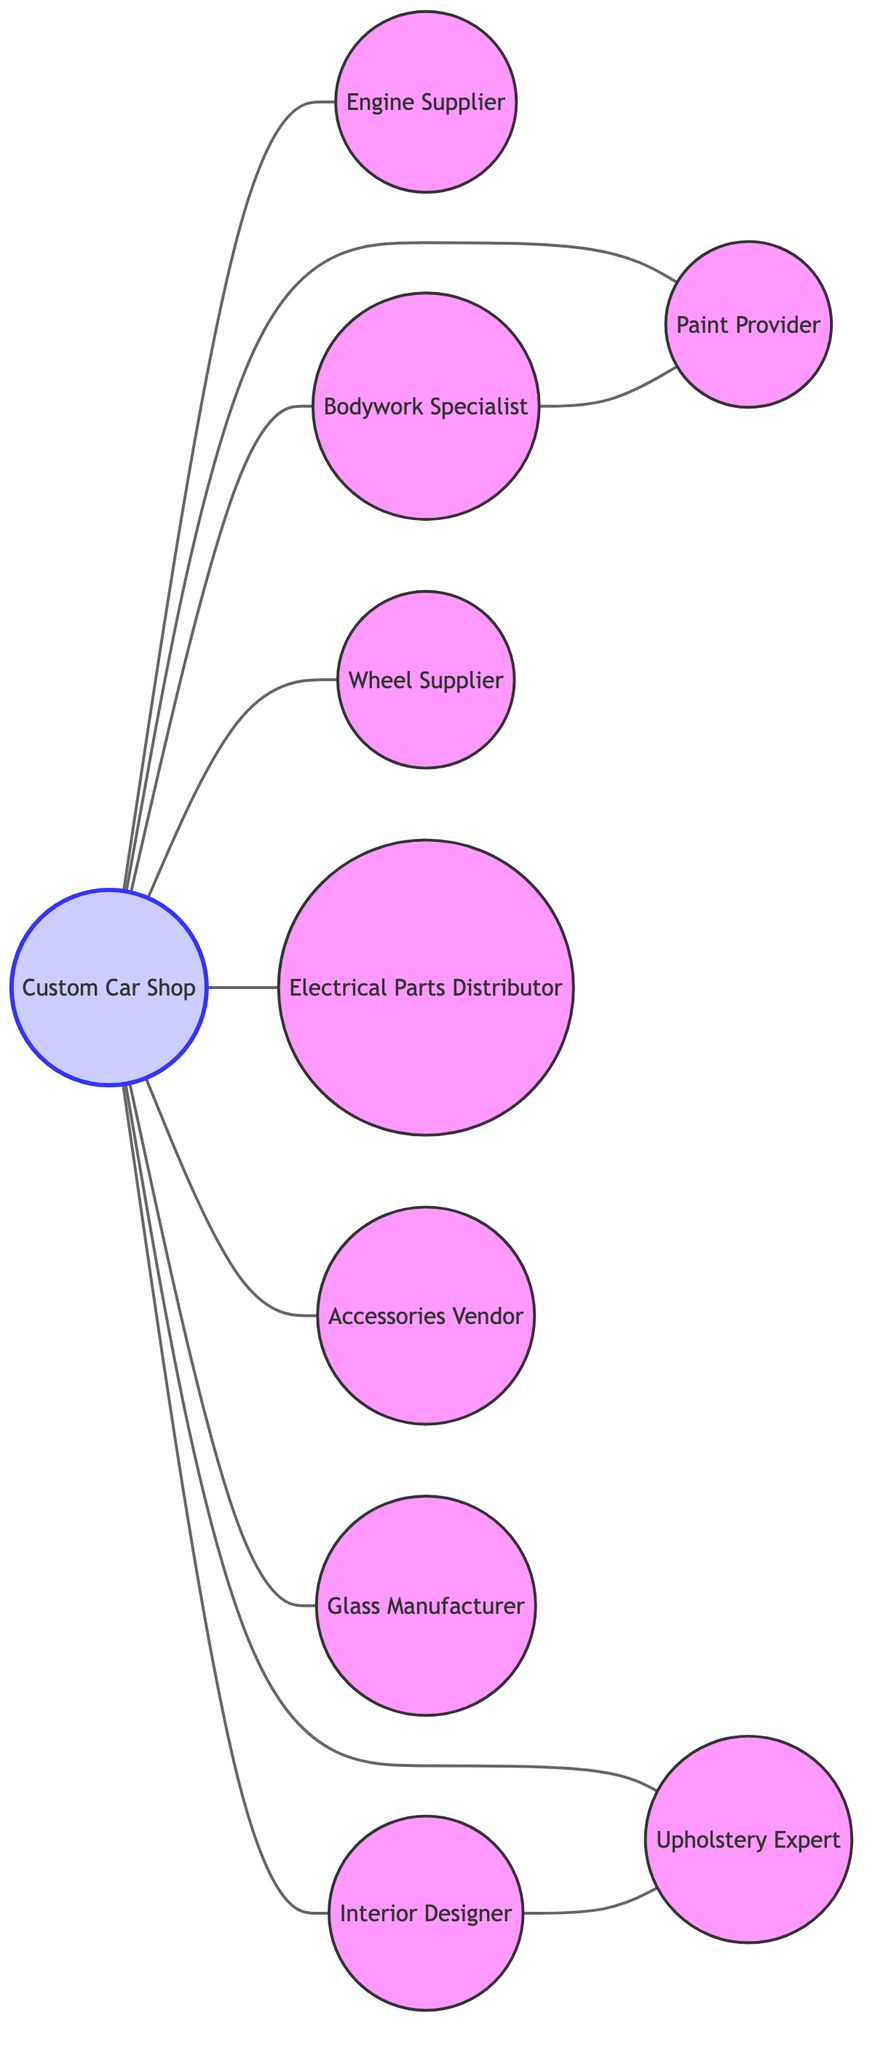What is the number of nodes in the diagram? The diagram contains a total of 10 nodes as listed, including the Custom Car Shop and all the various suppliers and specialists.
Answer: 10 Which supplier is directly connected to the Custom Car Shop? The Custom Car Shop is directly connected to nine suppliers, including engine supplier, bodywork specialist, paint provider, interior designer, wheel supplier, electrical parts distributor, accessories vendor, glass manufacturer, and upholstery expert.
Answer: Nine How many edges are present in the graph? By counting the edges listed, there are 10 edges present in the graph indicating the connections between the nodes.
Answer: 10 Which nodes are indirectly connected through the bodywork specialist? The bodywork specialist is connected to the paint provider, indicating that any connection from the Custom Car Shop to the bodywork specialist will lead to the paint provider.
Answer: Paint Provider How many suppliers are connected to the interior designer? The interior designer is directly connected to one supplier: the upholstery expert, showing a direct relationship in the graph.
Answer: One Which two suppliers are related through multiple connections? The engine supplier and upholstery expert are not directly but are part of a network with the Custom Car Shop as the central node, indicating an indirect relationship.
Answer: Custom Car Shop Is there a direct connection between the glass manufacturer and the accessories vendor? The graph indicates that there are no direct connections between the glass manufacturer and the accessories vendor, they are only connected through the Custom Car Shop.
Answer: No What are the roles of the connected nodes to the paint provider? The connected nodes to the paint provider are bodywork specialist and the Custom Car Shop, indicating that they are involved in a project involving paint application.
Answer: Custom Car Shop, Bodywork Specialist How many specialists have a direct relationship with the Custom Car Shop? The Custom Car Shop has direct relationships with eight specialists: engine supplier, bodywork specialist, paint provider, interior designer, wheel supplier, electrical parts distributor, accessories vendor, glass manufacturer, and upholstery expert.
Answer: Eight Which node does the interior designer connect with? The interior designer directly connects with the upholstery expert, indicating a collaboration between the two in custom car projects.
Answer: Upholstery Expert 